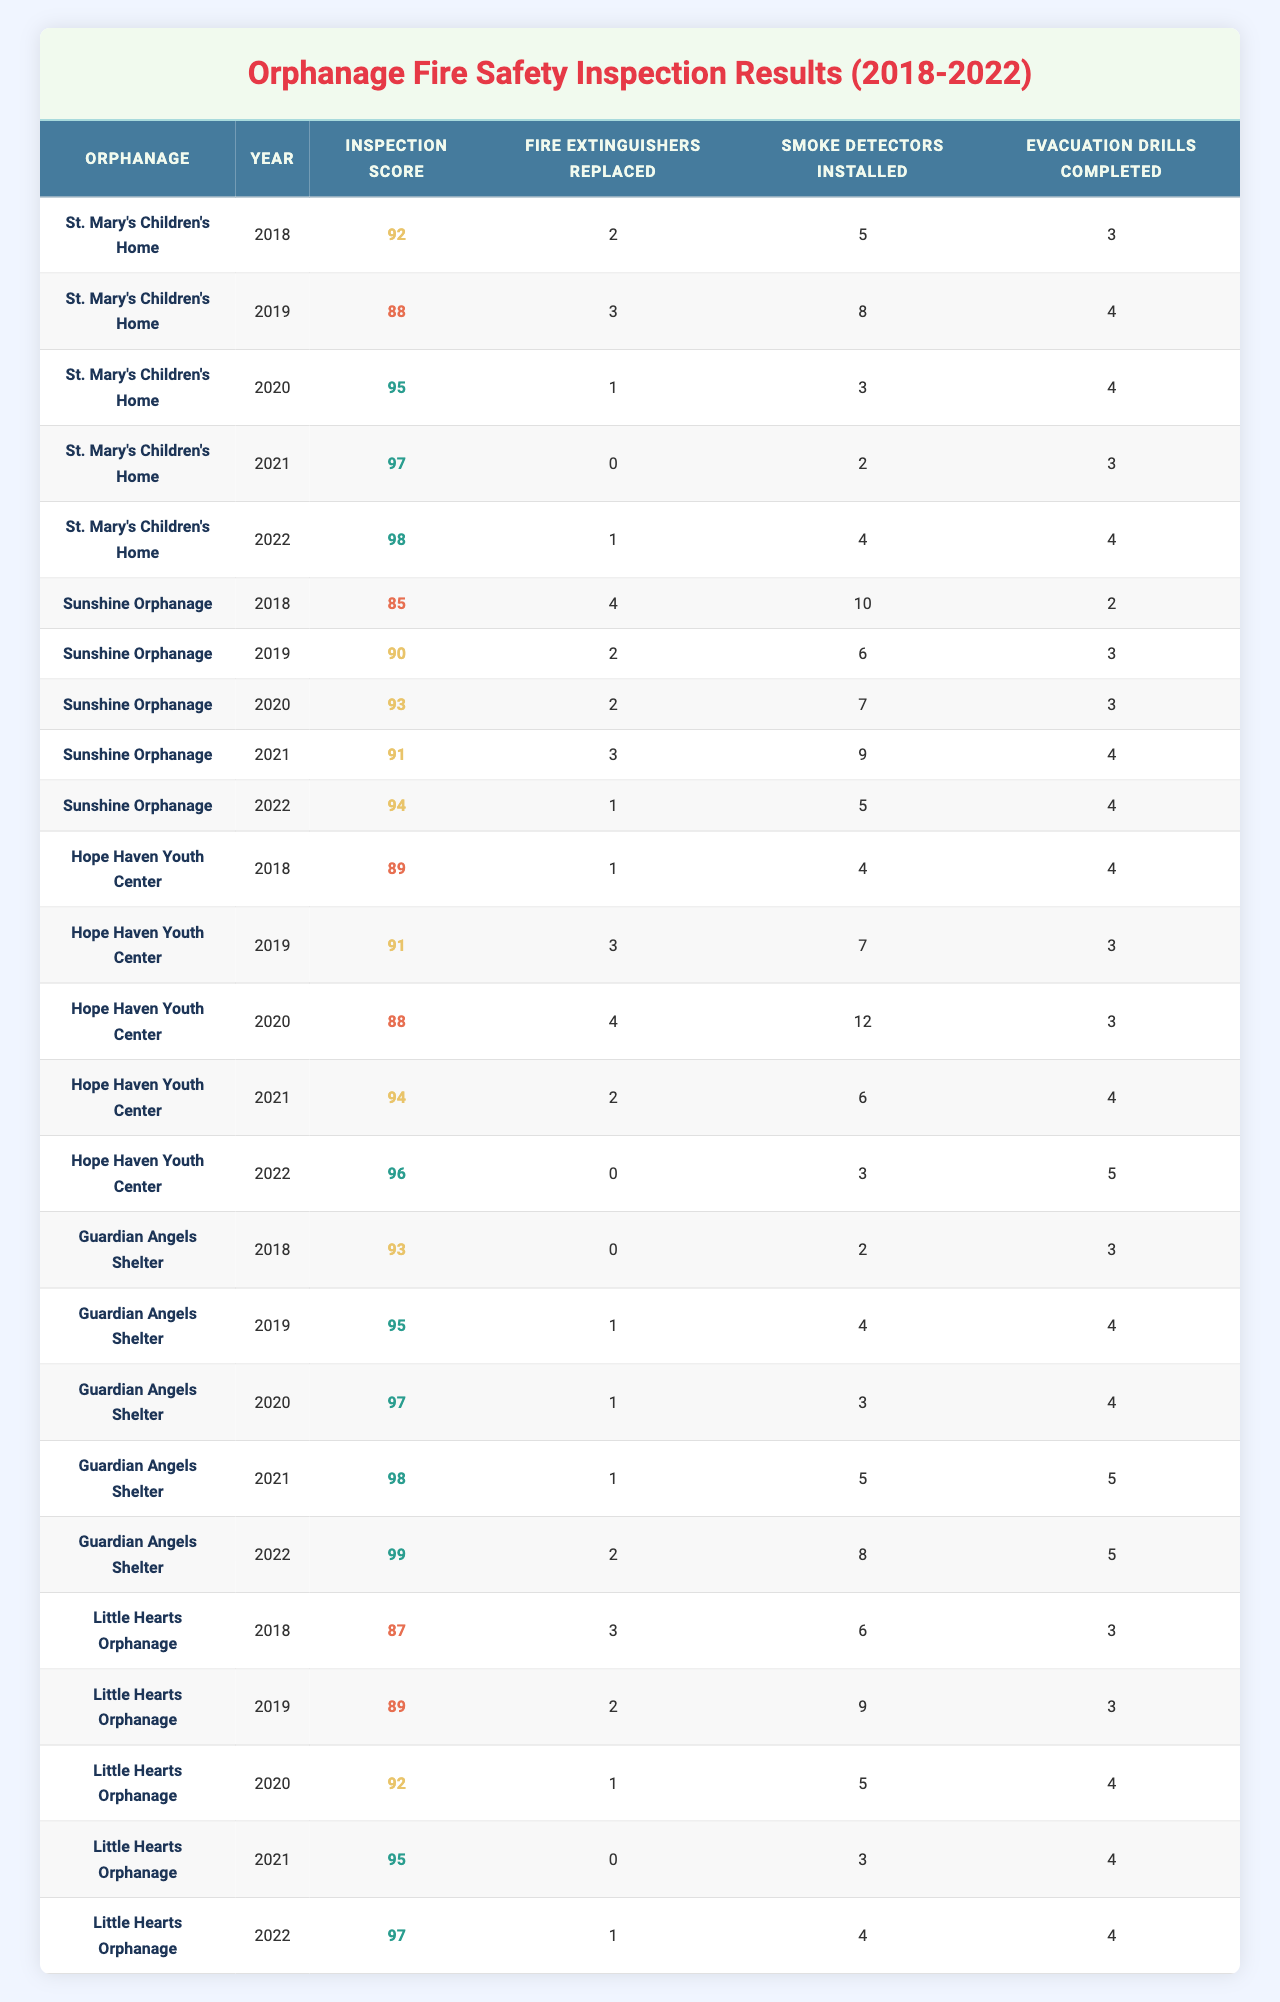What was the highest inspection score recorded in 2021? In 2021, the inspection scores for each orphanage are 97 (St. Mary's), 91 (Sunshine), 94 (Hope Haven), 98 (Guardian Angels), and 95 (Little Hearts). The highest score is 98 from Guardian Angels Shelter.
Answer: 98 Which orphanage replaced the most fire extinguishers in 2019? In 2019, the number of fire extinguishers replaced by the orphanages are: St. Mary's (3), Sunshine (2), Hope Haven (3), Guardian Angels (1), and Little Hearts (2). The most replacements were 3 by both St. Mary's and Hope Haven.
Answer: St. Mary's and Hope Haven What is the average number of smoke detectors installed across all orphanages in 2020? In 2020, smoke detectors installed are: St. Mary's (3), Sunshine (7), Hope Haven (12), Guardian Angels (3), and Little Hearts (5). The total is 30, and there are 5 orphanages, so the average is 30/5 = 6.
Answer: 6 Did Little Hearts Orphanage have a year with an inspection score below 90? Checking Little Hearts' scores: 87 (2018), 89 (2019), 92 (2020), 95 (2021), 97 (2022). The scores for 2018 and 2019 are below 90.
Answer: Yes What was the total number of evacuation drills completed by Hope Haven Youth Center from 2018 to 2022? The evacuation drills completed by Hope Haven from 2018 to 2022 are: 4 (2018), 3 (2019), 3 (2020), 4 (2021), and 5 (2022). Adding them gives 4 + 3 + 3 + 4 + 5 = 19 drills in total.
Answer: 19 Which year saw the least number of smoke detectors installed at Guardian Angels Shelter? The smoke detectors installed at Guardian Angels from 2018 to 2022 are: 2 (2018), 4 (2019), 3 (2020), 5 (2021), and 8 (2022). The least was in 2018 with 2 installed.
Answer: 2018 What is the trend in inspection scores for St. Mary's Children's Home over the years? St. Mary's scores are 92 (2018), 88 (2019), 95 (2020), 97 (2021), and 98 (2022). It has generally increased each year, from 88 in 2019 to 98 in 2022.
Answer: Increasing Were there any years when Sunshine Orphanage completed fewer than 3 evacuation drills? Sunshine's evacuation drills are 2 (2018), 3 (2019), 3 (2020), 4 (2021), and 4 (2022). There was only one year, 2018, with fewer than 3.
Answer: Yes Which orphanage had the best overall inspection score across all years? Total scores are: St. Mary's (92 + 88 + 95 + 97 + 98 = 470), Sunshine (85 + 90 + 93 + 91 + 94 = 453), Hope Haven (89 + 91 + 88 + 94 + 96 = 458), Guardian Angels (93 + 95 + 97 + 98 + 99 = 482), and Little Hearts (87 + 89 + 92 + 95 + 97 = 460). Guardian Angels has the best overall with 482.
Answer: Guardian Angels Shelter How many fire extinguishers were replaced by Little Hearts Orphanage over the entire period? The total replacements for Little Hearts from 2018 to 2022 are: 3 (2018), 2 (2019), 1 (2020), 0 (2021), and 1 (2022), which totals 3 + 2 + 1 + 0 + 1 = 7 extinguishers.
Answer: 7 